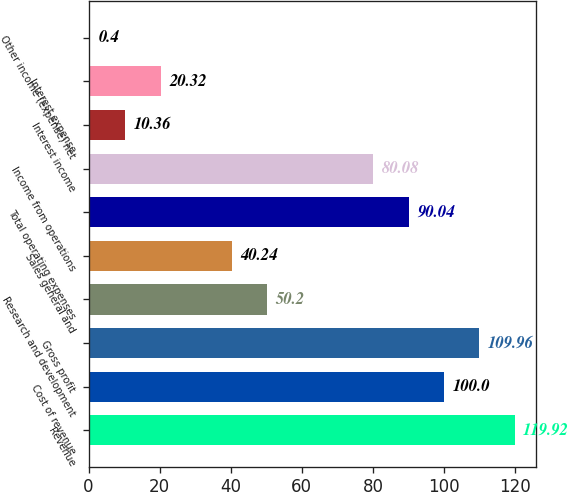<chart> <loc_0><loc_0><loc_500><loc_500><bar_chart><fcel>Revenue<fcel>Cost of revenue<fcel>Gross profit<fcel>Research and development<fcel>Sales general and<fcel>Total operating expenses<fcel>Income from operations<fcel>Interest income<fcel>Interest expense<fcel>Other income (expense) net<nl><fcel>119.92<fcel>100<fcel>109.96<fcel>50.2<fcel>40.24<fcel>90.04<fcel>80.08<fcel>10.36<fcel>20.32<fcel>0.4<nl></chart> 